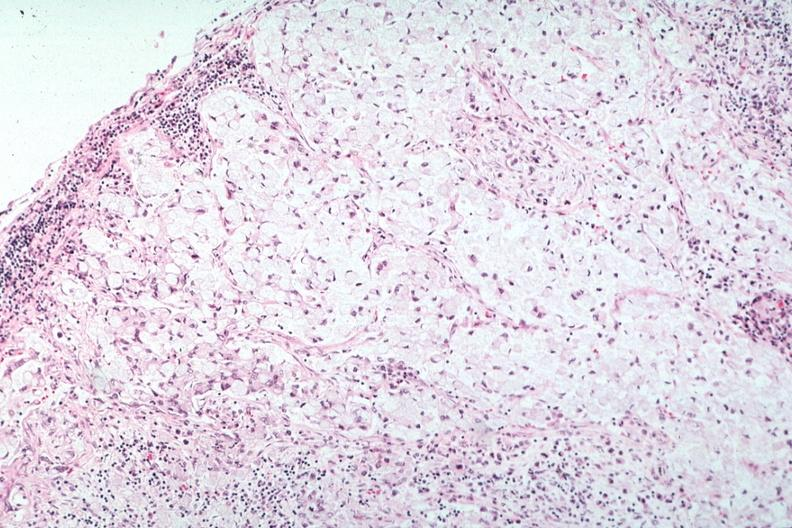does this image show stomach primary?
Answer the question using a single word or phrase. Yes 